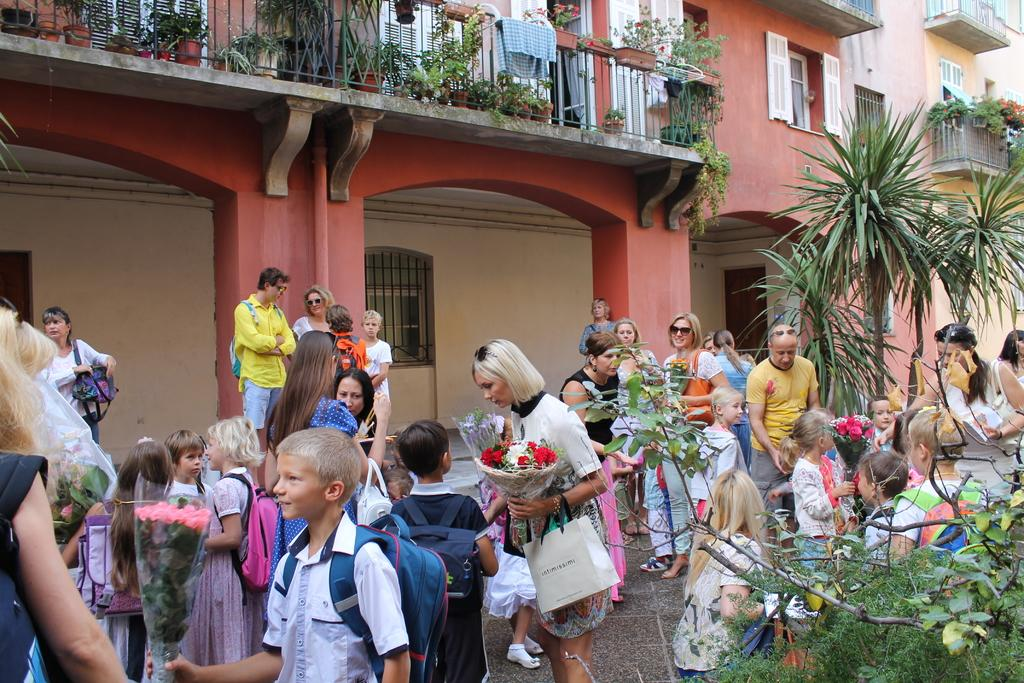How many people are present in the image? There are people in the image, but the exact number is not specified. What are some of the people doing in the image? Some people are carrying objects in the image. What can be seen in the background of the image? There are two buildings and trees in the background of the image. Are there any plants visible in the image? Yes, there are potted plants in the image. Can you see an airplane flying over the buildings in the image? There is no mention of an airplane in the image, so it cannot be confirmed or denied. Is there a battle taking place between the people in the image? There is no indication of a battle or any conflict in the image. 